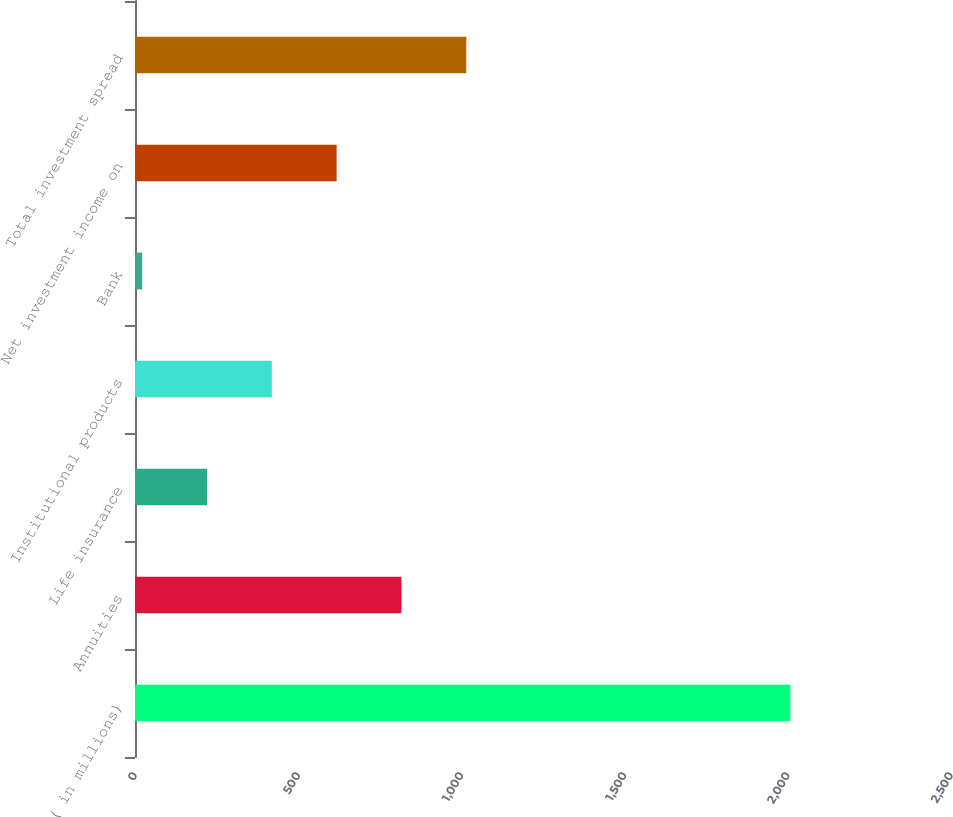Convert chart. <chart><loc_0><loc_0><loc_500><loc_500><bar_chart><fcel>( in millions)<fcel>Annuities<fcel>Life insurance<fcel>Institutional products<fcel>Bank<fcel>Net investment income on<fcel>Total investment spread<nl><fcel>2008<fcel>816.4<fcel>220.6<fcel>419.2<fcel>22<fcel>617.8<fcel>1015<nl></chart> 